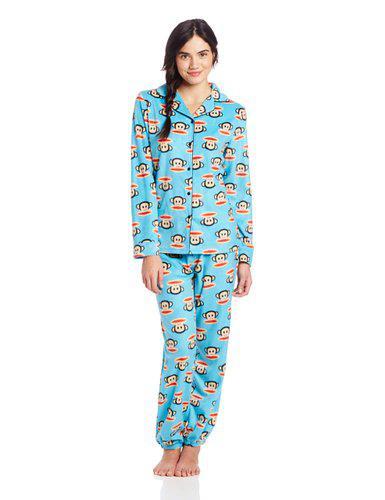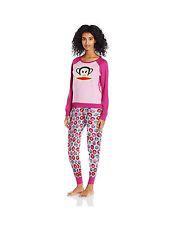The first image is the image on the left, the second image is the image on the right. Assess this claim about the two images: "Pajama shirts in both images have sleeves the same length.". Correct or not? Answer yes or no. Yes. 